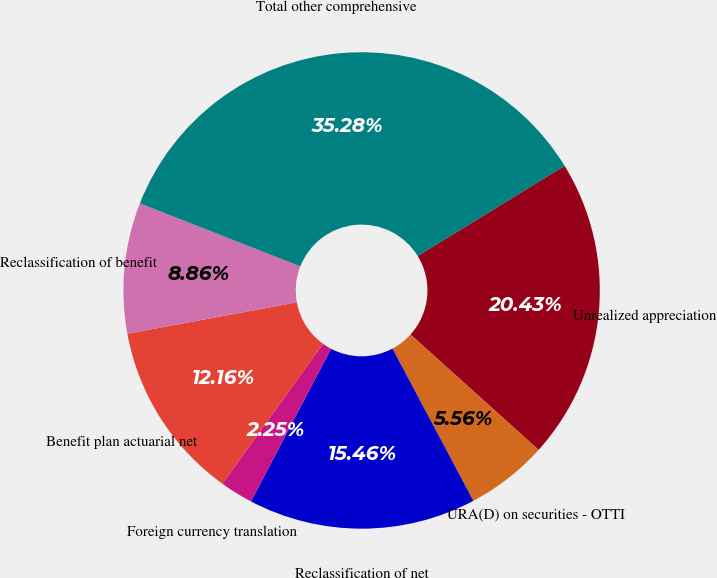Convert chart to OTSL. <chart><loc_0><loc_0><loc_500><loc_500><pie_chart><fcel>Unrealized appreciation<fcel>URA(D) on securities - OTTI<fcel>Reclassification of net<fcel>Foreign currency translation<fcel>Benefit plan actuarial net<fcel>Reclassification of benefit<fcel>Total other comprehensive<nl><fcel>20.43%<fcel>5.56%<fcel>15.46%<fcel>2.25%<fcel>12.16%<fcel>8.86%<fcel>35.28%<nl></chart> 